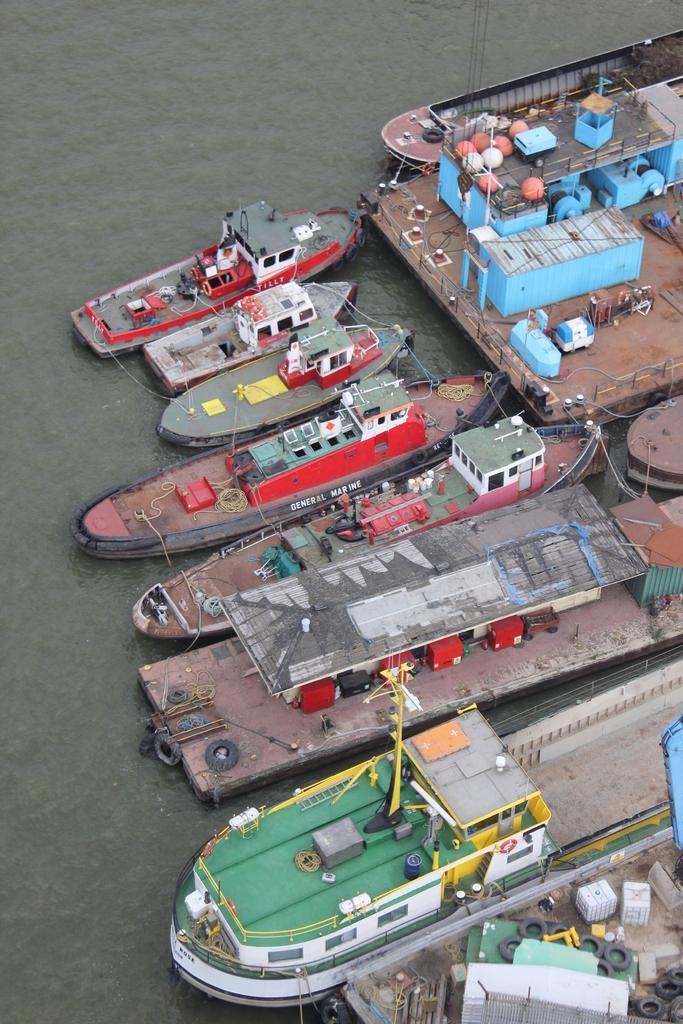Where was the image taken? The image was taken in a shipyard. What can be seen in the water in the image? There are boats and ships in the water. What structure is present near the water in the image? There is a dock in the image. What other objects related to a shipyard can be seen in the image? There are other objects related to a shipyard in the image. What type of jewel is being polished on the dock in the image? There is no jewel present in the image; it is a shipyard with boats, ships, and other related objects. 